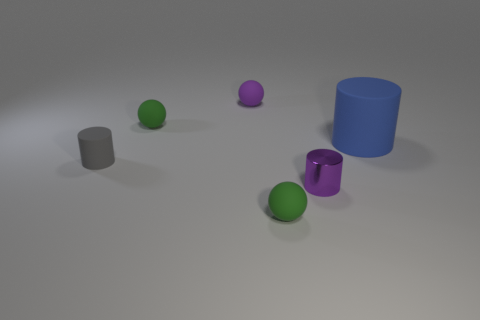Are there any other things that have the same size as the blue matte cylinder?
Provide a succinct answer. No. What is the shape of the small green matte object that is in front of the large blue rubber thing?
Offer a very short reply. Sphere. There is a small green rubber thing that is behind the large cylinder that is right of the small purple metallic cylinder; is there a rubber object that is in front of it?
Provide a succinct answer. Yes. Is there any other thing that has the same shape as the gray object?
Provide a succinct answer. Yes. Is there a red metallic cylinder?
Offer a very short reply. No. Are the small green thing that is in front of the large cylinder and the small cylinder in front of the small gray matte object made of the same material?
Provide a short and direct response. No. What is the size of the green rubber ball to the left of the green matte thing in front of the tiny green object behind the tiny gray cylinder?
Provide a succinct answer. Small. How many tiny balls have the same material as the blue cylinder?
Your response must be concise. 3. Is the number of green things less than the number of small rubber cylinders?
Offer a terse response. No. There is another rubber thing that is the same shape as the tiny gray object; what size is it?
Your response must be concise. Large. 